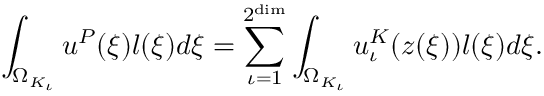<formula> <loc_0><loc_0><loc_500><loc_500>\int _ { \Omega _ { K _ { \iota } } } u ^ { P } ( \xi ) l ( \xi ) d \xi = \sum _ { \iota = 1 } ^ { 2 ^ { \dim } } \int _ { \Omega _ { K _ { \iota } } } u _ { \iota } ^ { K } ( z ( \xi ) ) l ( \xi ) d \xi .</formula> 